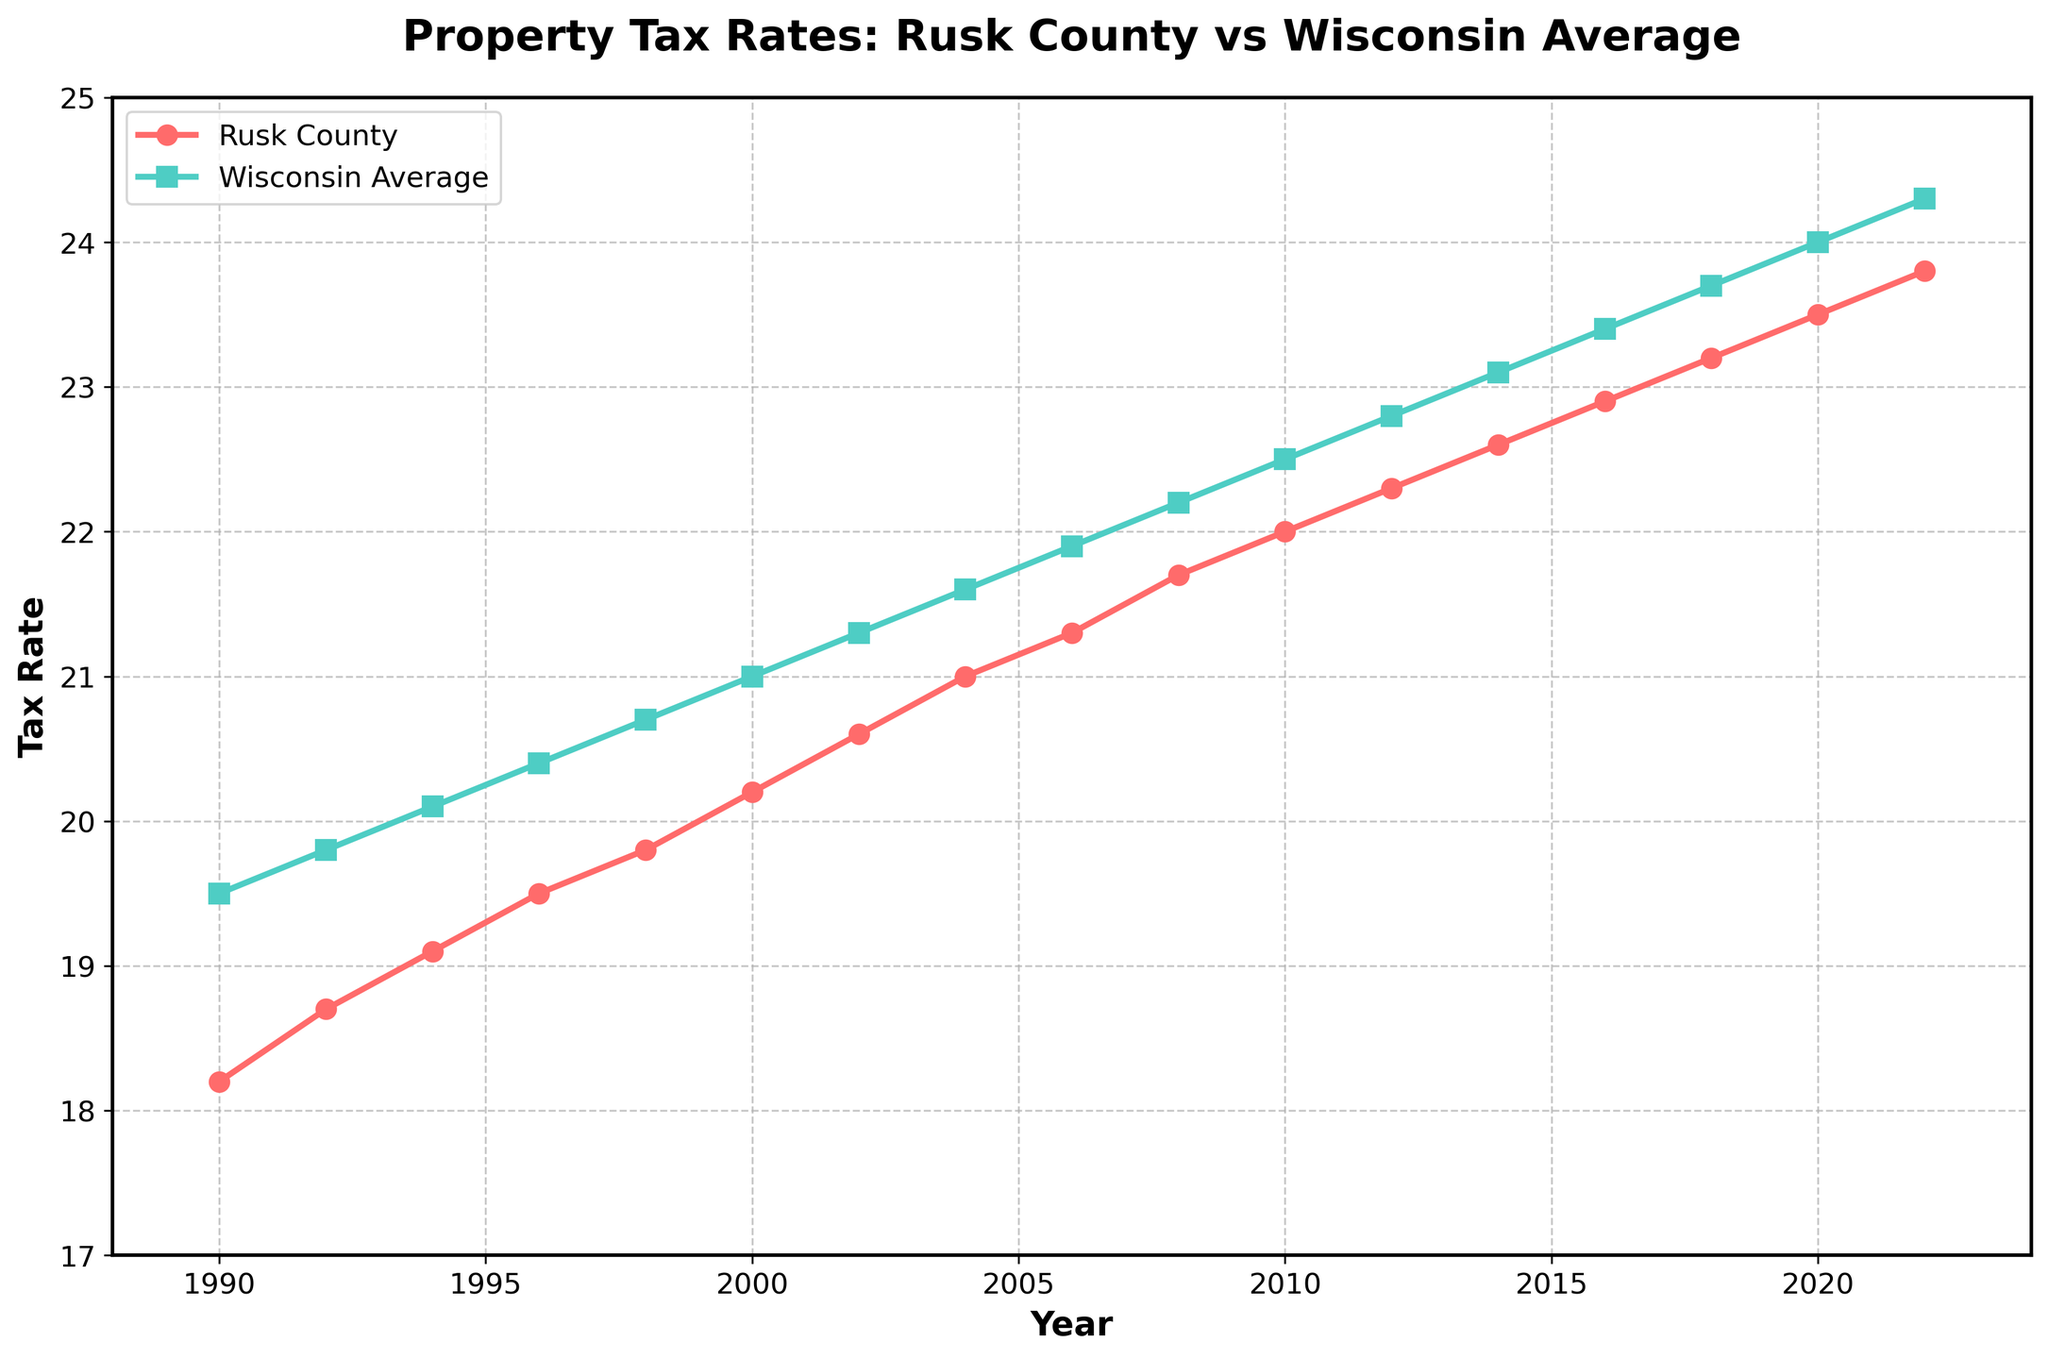How has the property tax rate in Rusk County changed from 1990 to 2022? To answer this, observe the line representing Rusk County's property tax rate. It starts at 18.2 in 1990 and increases gradually each year until it reaches 23.8 in 2022.
Answer: The tax rate increased from 18.2 to 23.8 Is Rusk County's property tax rate ever higher than the Wisconsin average during this period? By comparing the two lines, we see that the Rusk County tax rate consistently remains below the Wisconsin average from 1990 to 2022.
Answer: No, it is always lower What is the average tax rate for Rusk County from 1990 to 2022? Add up all the tax rates for Rusk County from 1990 to 2022 and divide by the number of years. The sum is (18.2 + 18.7 + 19.1 + 19.5 + 19.8 + 20.2 + 20.6 + 21.0 + 21.3 + 21.7 + 22.0 + 22.3 + 22.6 + 22.9 + 23.2 + 23.5 + 23.8 = 370.4). Divide by 17 years.
Answer: 21.79 Which year had the smallest difference between Rusk County's tax rate and the Wisconsin average? Calculate the difference between Rusk County's tax rate and the Wisconsin average for each year, then find the smallest one. Rusk: 18.2, WI: 19.5, Difference: 1.3 (1990), and so on.
Answer: 1994 (0.75 difference) By how much did Rusk County's tax rate increase between 2000 and 2010? The tax rate in 2000 was 20.2, and in 2010, it was 22.0. Subtract the earlier value from the later value (22.0 - 20.2) to find the increase.
Answer: 1.8 What is the trend in the percent difference between Rusk County's tax rate and the Wisconsin average over time? Calculate the percent difference for each year: ((Wisconsin - Rusk) / Wisconsin) * 100. Observe if the percent difference increases, decreases, or remains stable. In 1990: (19.5 - 18.2) / 19.5 ≈ 6.67%, in 2022: (24.3 - 23.8) / 24.3 ≈ 2.06%.
Answer: Decreasing trend In which year do both Rusk County and the Wisconsin average have the same relative increase compared to their previous values? Calculate the relative increase for both (current year / previous year - 1) and find the year where both changes are equal. For example, from 1990 to 1992, Rusk: (18.7/18.2 - 1) ≈ 2.75%, WI: (19.8/19.5 - 1) ≈ 1.54%. Repeat for other intervals.
Answer: 2012 (approximately similar increases for both: Rusk ≈ 1.36%, WI ≈ 1.32%) During which period did Rusk County see a faster increase in property tax rate compared to the Wisconsin average? Identify periods where the slope (rate of increase) of the Rusk County line is steeper than that of Wisconsin. Compare trends from year to year.
Answer: 1996 to 2002 